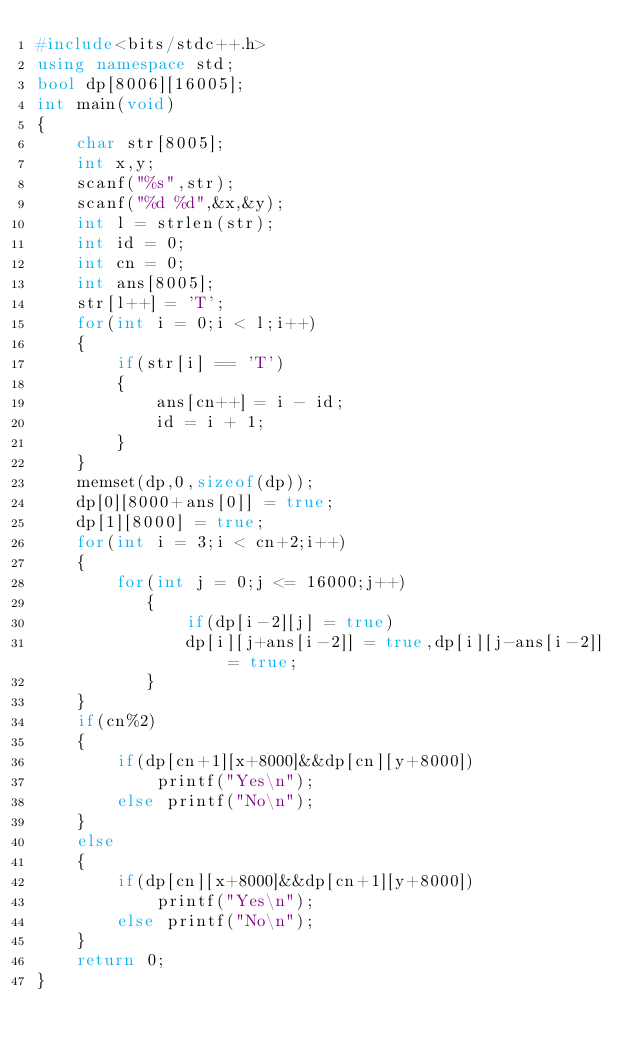Convert code to text. <code><loc_0><loc_0><loc_500><loc_500><_C++_>#include<bits/stdc++.h>
using namespace std;
bool dp[8006][16005];
int main(void)
{
    char str[8005];
    int x,y;
    scanf("%s",str);
    scanf("%d %d",&x,&y);
    int l = strlen(str);
    int id = 0;
    int cn = 0;
    int ans[8005];
    str[l++] = 'T';
    for(int i = 0;i < l;i++)
    {
        if(str[i] == 'T')
        {
            ans[cn++] = i - id;
            id = i + 1;
        }
    }
    memset(dp,0,sizeof(dp));
    dp[0][8000+ans[0]] = true;
    dp[1][8000] = true;
    for(int i = 3;i < cn+2;i++)
    {
        for(int j = 0;j <= 16000;j++)
           {
               if(dp[i-2][j] = true)
               dp[i][j+ans[i-2]] = true,dp[i][j-ans[i-2]] = true;
           }
    }
    if(cn%2)
    {
        if(dp[cn+1][x+8000]&&dp[cn][y+8000])
            printf("Yes\n");
        else printf("No\n");
    }
    else
    {
        if(dp[cn][x+8000]&&dp[cn+1][y+8000])
            printf("Yes\n");
        else printf("No\n");
    }
    return 0;
}
</code> 